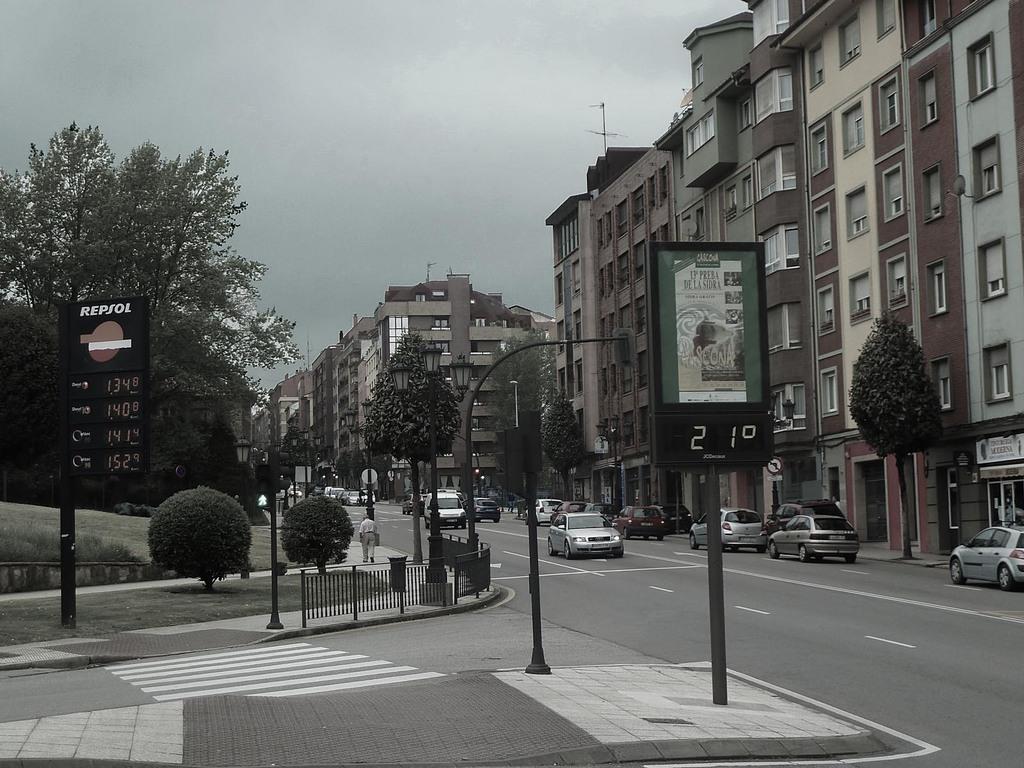What temperature is on the sign?
Your answer should be compact. 21. What company has a red circle?
Provide a succinct answer. Repsol. 